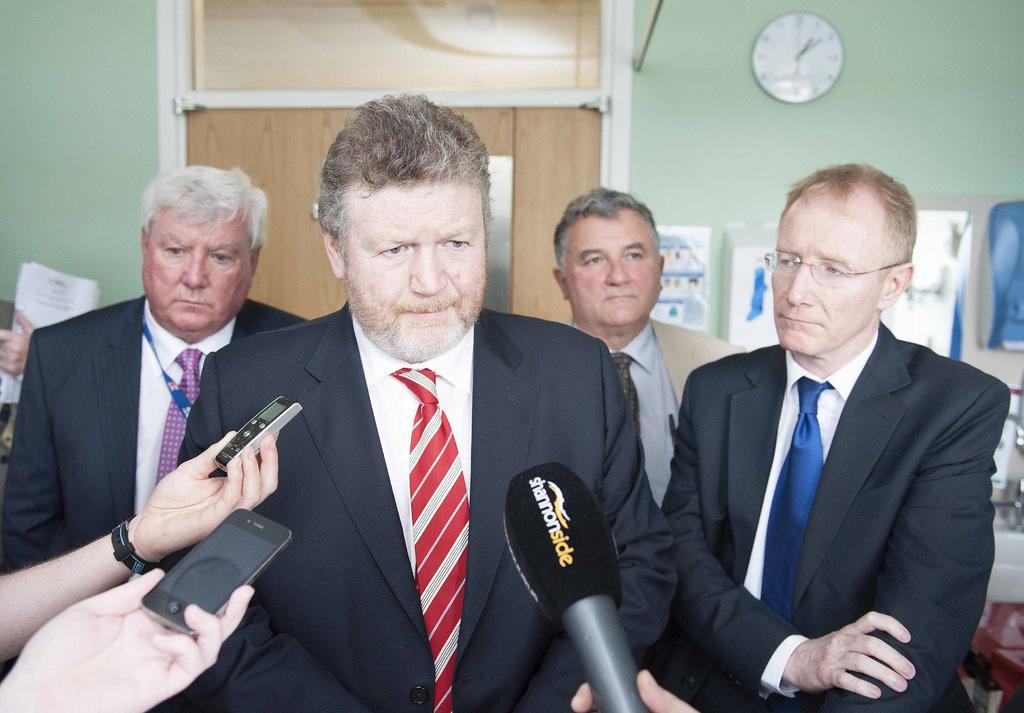How would you summarize this image in a sentence or two? In this image we can see four men. They are wearing coats, shirts and tie. We can see a mic and human hand at the bottom of the image. In the left bottom of the image, we can see two human hands are holdings mobiles. In the background, we can see wall, door, posters and the clock on the wall. We can see some objects on the right side of the image. 